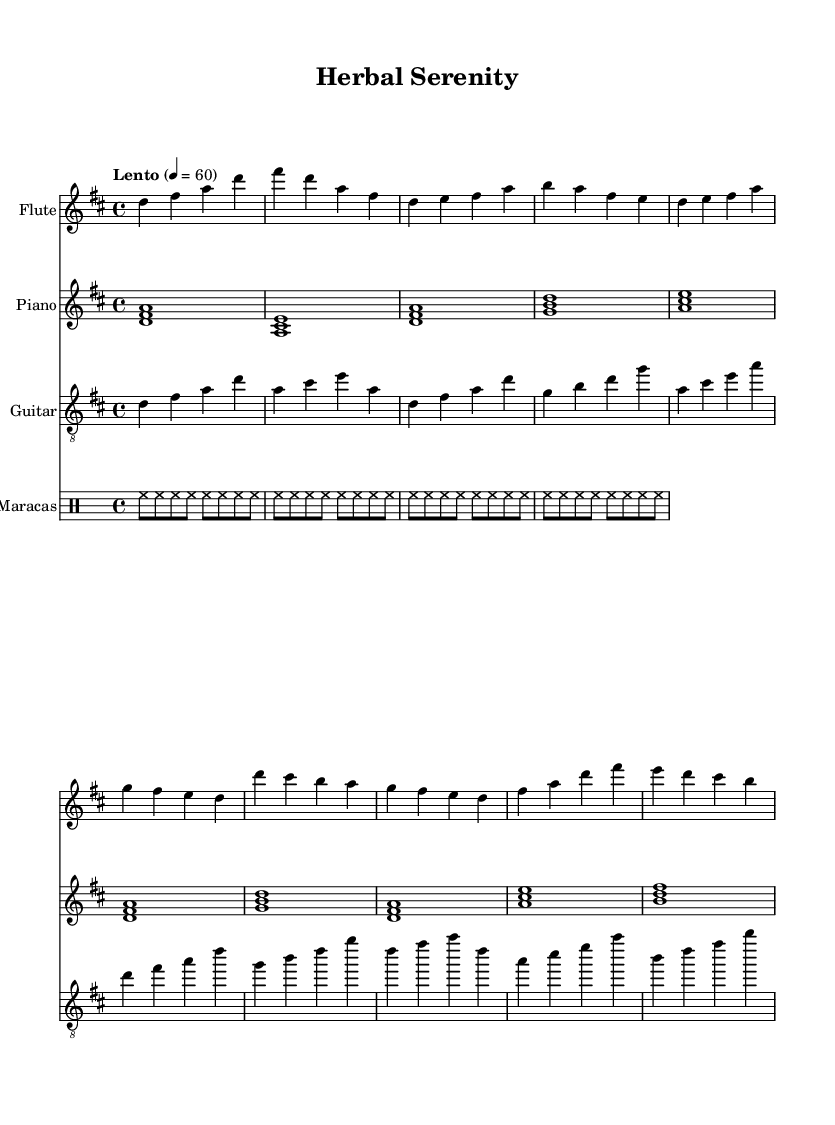What is the key signature of this music? The key signature is D major, indicated by the presence of sharps in the sheet music. Specifically, there are two sharps: F# and C#. This information can be found in the "global" section of the code where it specifies "\key d \major".
Answer: D major What is the time signature of this music? The time signature is 4/4, which is indicated in the "global" section of the code with "\time 4/4". This means there are four beats in each measure, and the quarter note gets one beat.
Answer: 4/4 What is the tempo marking in the music? The tempo marking is "Lento", which indicates a slow pace. This is denoted in the "global" section with the expression "\tempo "Lento" 4 = 60". This suggests the music should be played slowly, at 60 beats per minute.
Answer: Lento How many instruments are featured in this score? The score includes four instruments: Flute, Piano, Guitar, and Maracas. This can be derived from the "score" section where four new staffs are created for each instrument separately.
Answer: Four What type of rhythmic pattern is used in the maracas part? The rhythmic pattern in the maracas part consists of consistent eighth notes throughout the measures. This is specified in the "maracas" drummode section where it is shown as "hh8", indicating a steady beating pattern.
Answer: Eighth notes What musical form does the piece utilize based on the structure? The piece utilizes a structure resembling the traditional verse-chorus form. This can be observed through the arrangement of the introductory, verse, and chorus sections in the flute, piano, and guitar parts, indicating repetition and variation typical of this form.
Answer: Verse-chorus Which sound elements are incorporated into this meditative music? The music incorporates nature sounds and herbal essences conceptually, but these elements are not directly represented in the sheet music itself. The overall theme relates to the use of serene melodies and gentle rhythms that evoke a peaceful, natural ambiance.
Answer: Nature sounds 